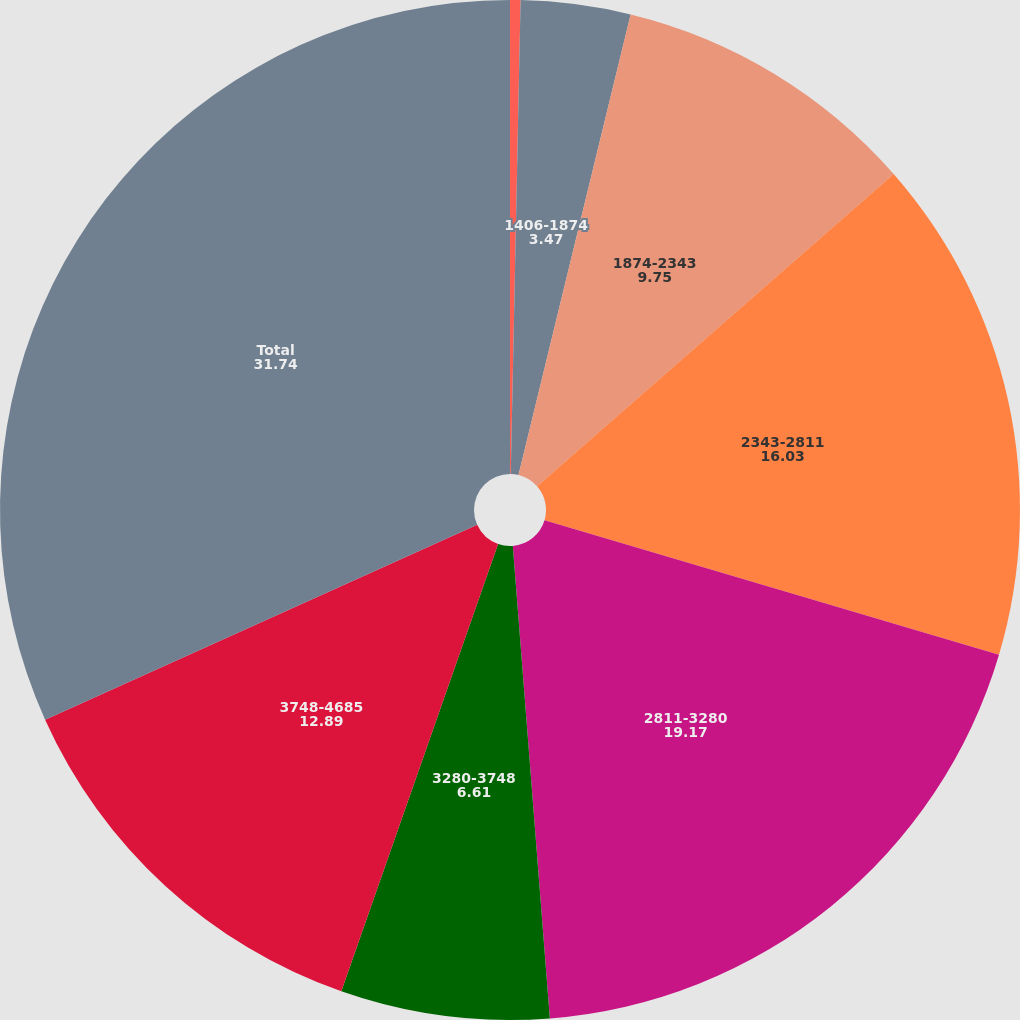Convert chart to OTSL. <chart><loc_0><loc_0><loc_500><loc_500><pie_chart><fcel>937-1406<fcel>1406-1874<fcel>1874-2343<fcel>2343-2811<fcel>2811-3280<fcel>3280-3748<fcel>3748-4685<fcel>Total<nl><fcel>0.33%<fcel>3.47%<fcel>9.75%<fcel>16.03%<fcel>19.17%<fcel>6.61%<fcel>12.89%<fcel>31.74%<nl></chart> 